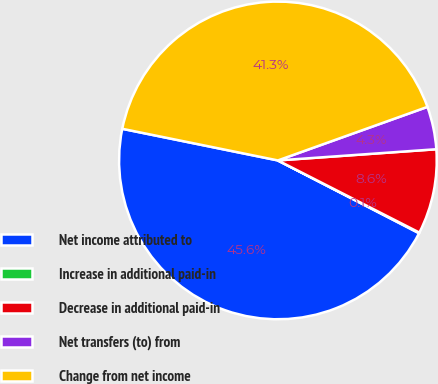Convert chart to OTSL. <chart><loc_0><loc_0><loc_500><loc_500><pie_chart><fcel>Net income attributed to<fcel>Increase in additional paid-in<fcel>Decrease in additional paid-in<fcel>Net transfers (to) from<fcel>Change from net income<nl><fcel>45.62%<fcel>0.07%<fcel>8.63%<fcel>4.35%<fcel>41.34%<nl></chart> 